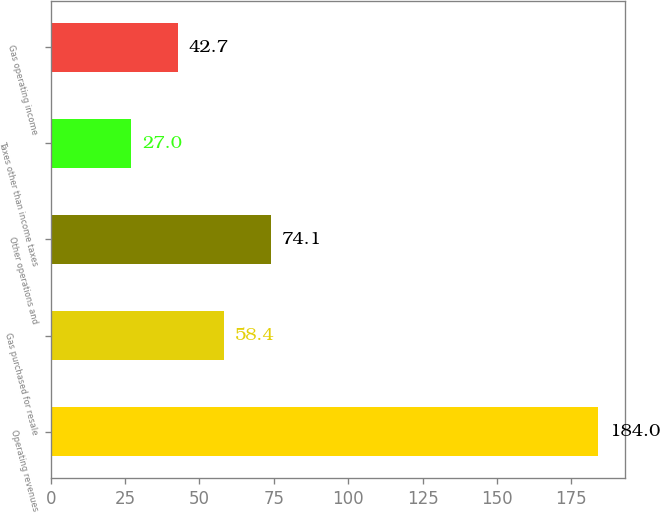Convert chart to OTSL. <chart><loc_0><loc_0><loc_500><loc_500><bar_chart><fcel>Operating revenues<fcel>Gas purchased for resale<fcel>Other operations and<fcel>Taxes other than income taxes<fcel>Gas operating income<nl><fcel>184<fcel>58.4<fcel>74.1<fcel>27<fcel>42.7<nl></chart> 